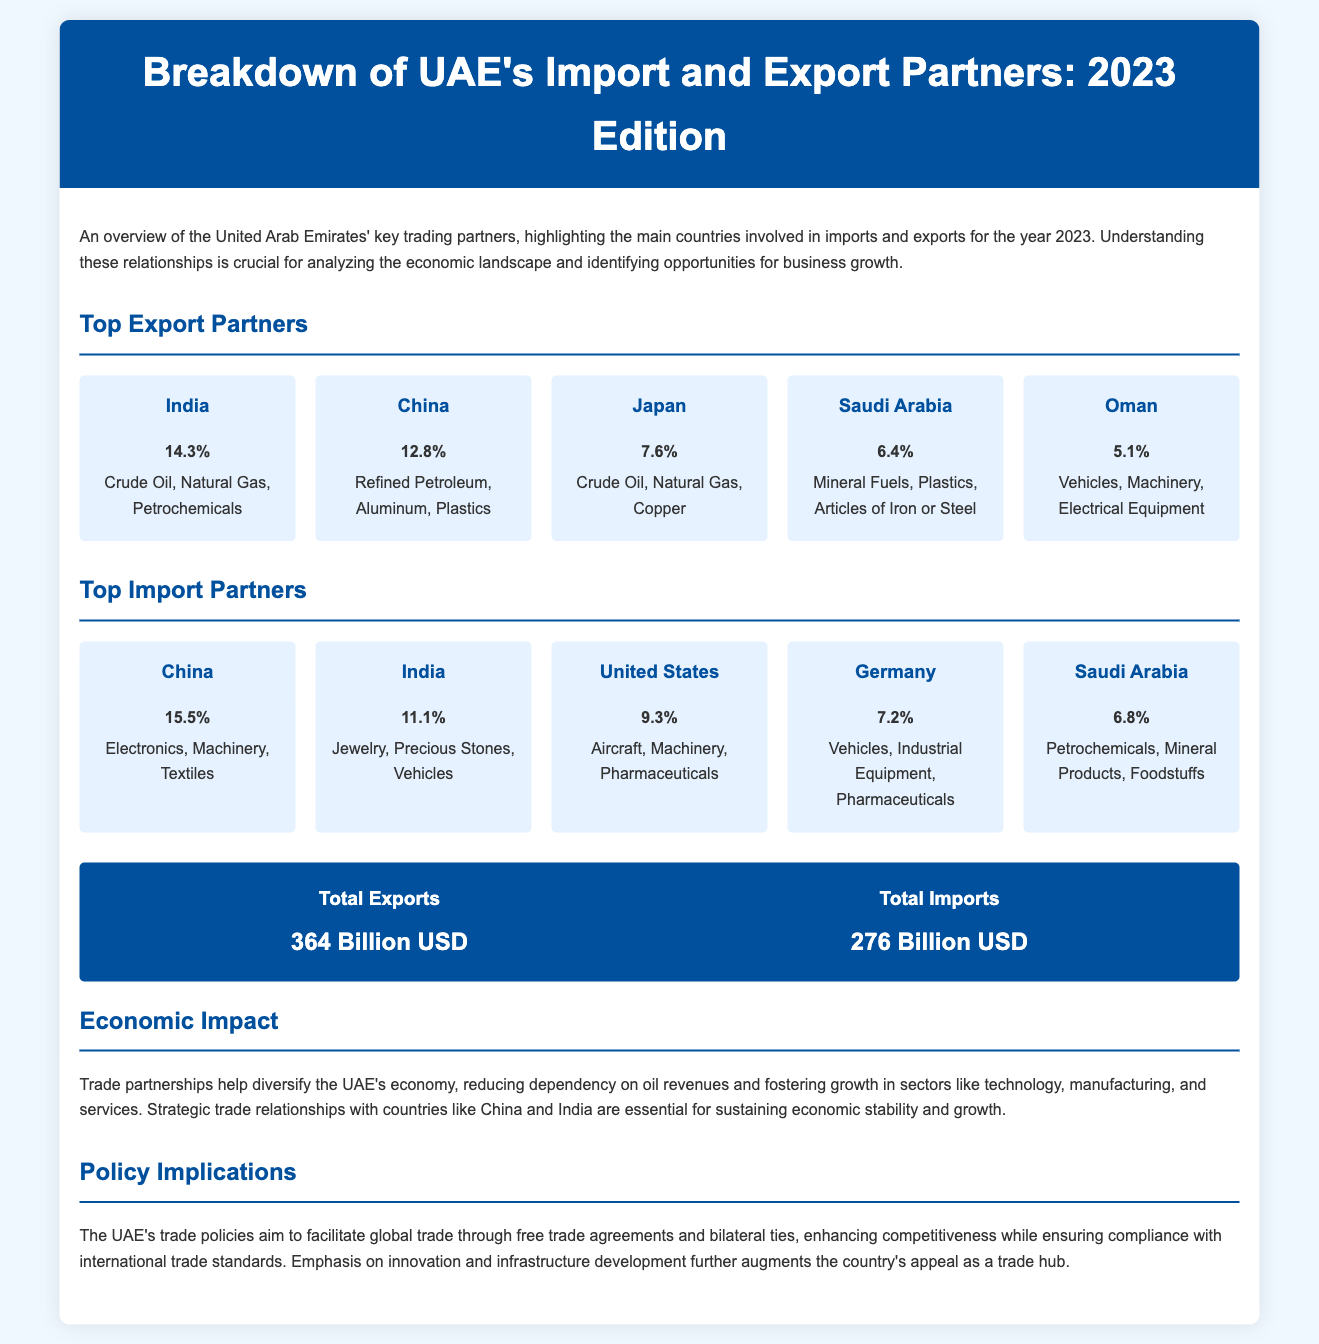What is the largest export partner of the UAE? The UAE's largest export partner is India, which accounts for 14.3% of exports.
Answer: India What percentage of UAE's exports does China represent? China represents 12.8% of the UAE's exports, making it the second-largest export partner.
Answer: 12.8% What are the main export products to Japan? The main export products to Japan include Crude Oil, Natural Gas, and Copper.
Answer: Crude Oil, Natural Gas, Copper Which country is the top import partner for the UAE? China's contribution is the highest at 15.5%, making it the top import partner of the UAE.
Answer: China What is the total value of UAE's exports in USD? The total value of UAE's exports is stated as 364 Billion USD in the document.
Answer: 364 Billion USD How much does the UAE import from India? The document states that India comprises 11.1% of the UAE's imports, indicating its significance.
Answer: 11.1% What is the trade relationship focus mentioned in the Economic Impact section? The trade partnerships help diversify the UAE's economy, reducing dependency on oil revenues.
Answer: Diversification of economy What is the total value of UAE's imports in USD? The total value of UAE's imports is mentioned as 276 Billion USD.
Answer: 276 Billion USD What percentage of imports does the United States represent? The United States comprises 9.3% of the UAE's imports, highlighting its role as an important trade partner.
Answer: 9.3% What is one of the strategic focuses of the UAE's trade policies? The document mentions that the emphasis on innovation and infrastructure development is a key focus.
Answer: Innovation and infrastructure development 